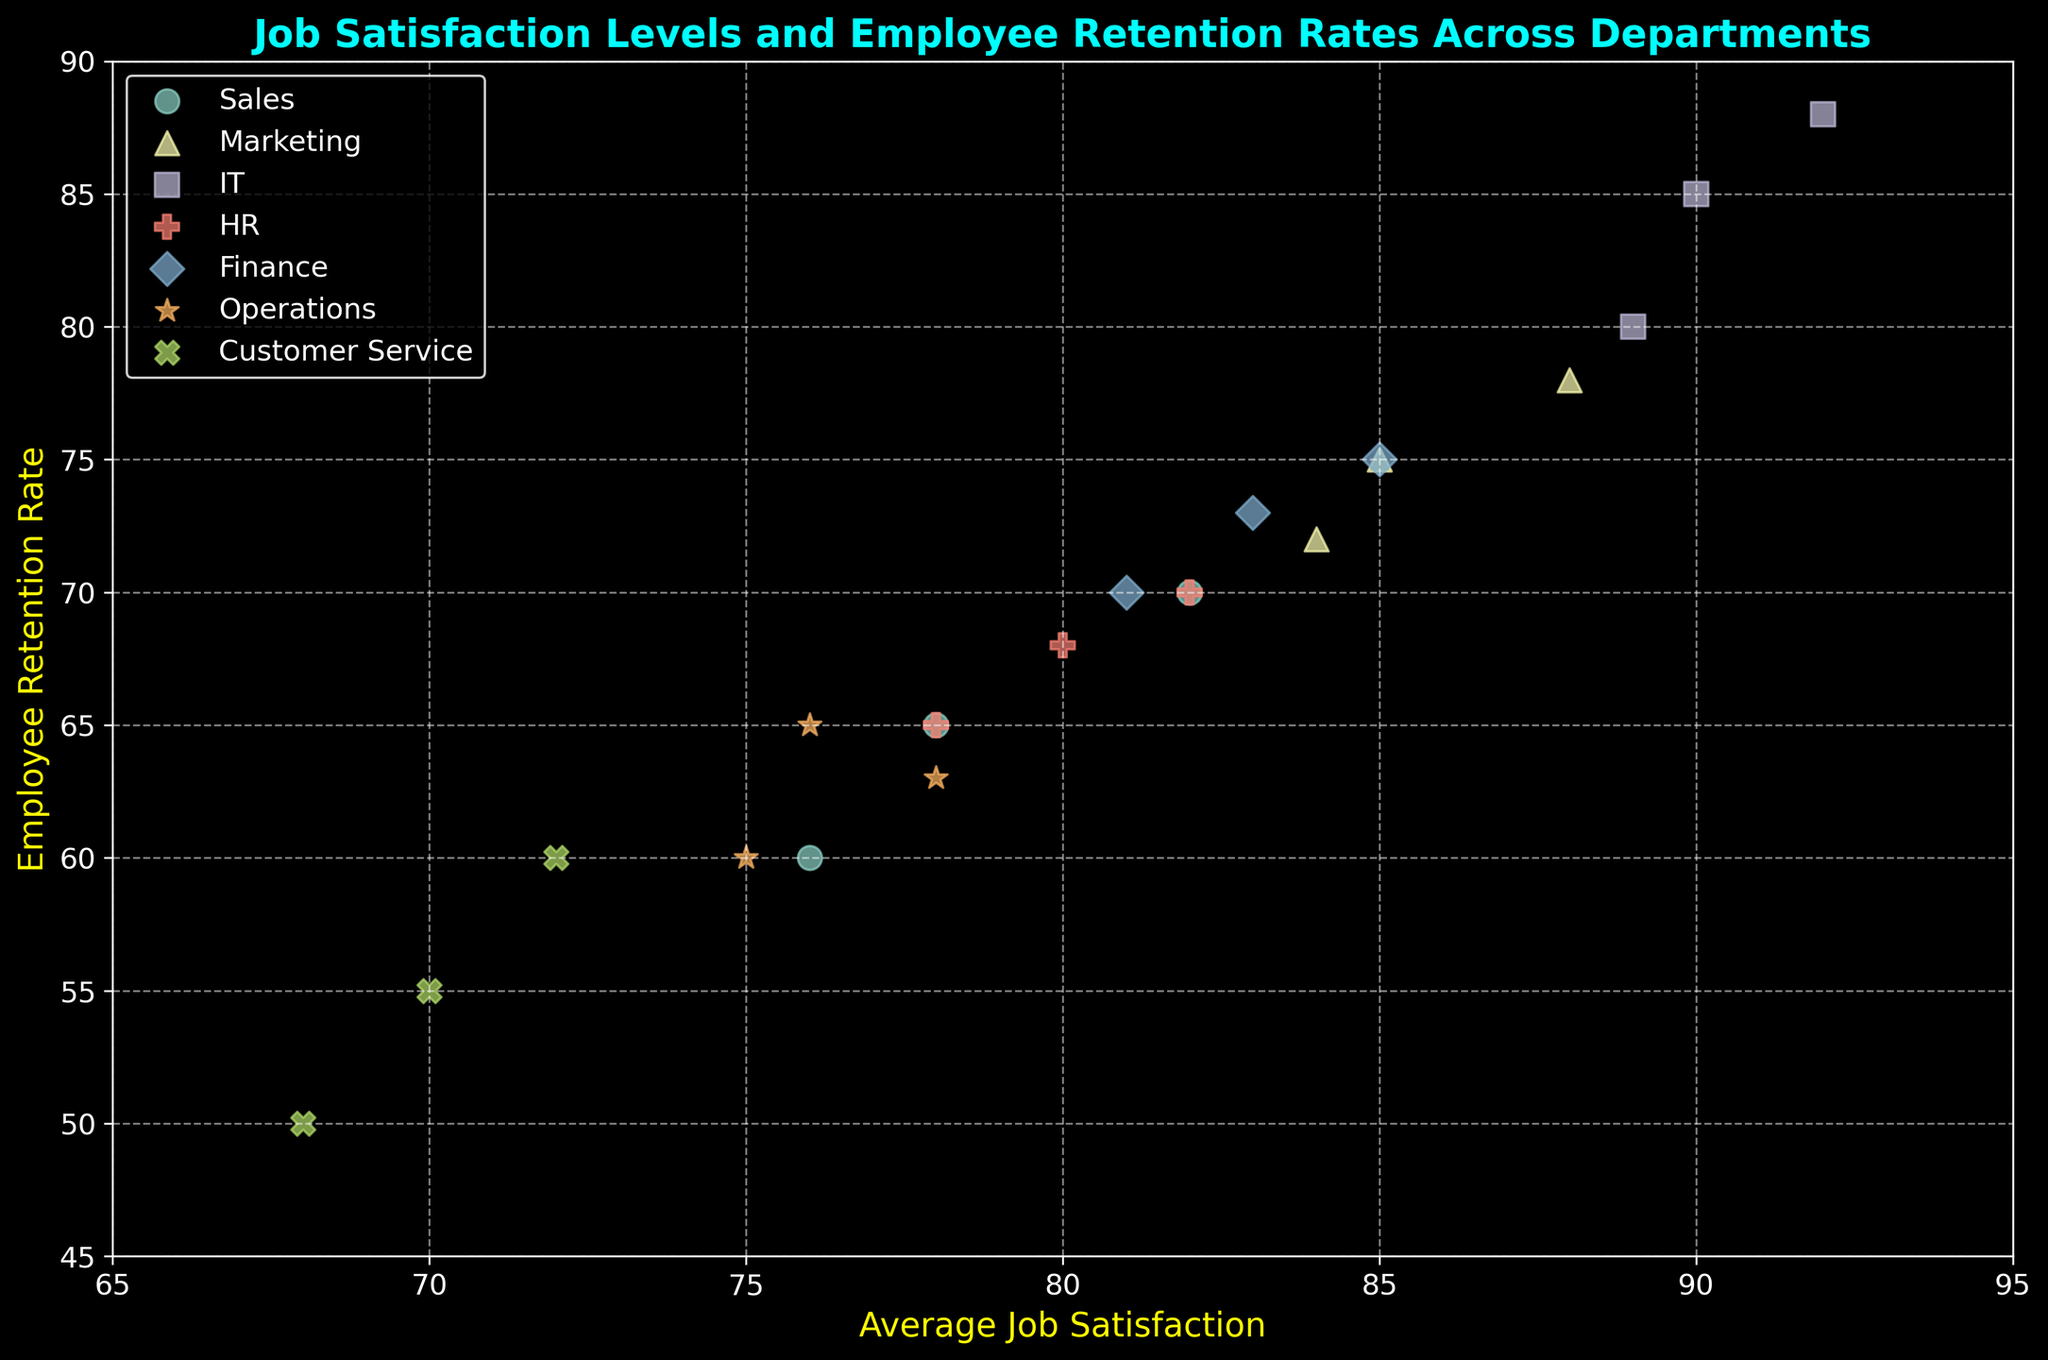What department has the highest average job satisfaction? Look at the x-axis values for all points and identify the department with the highest x-axis value. The IT department shows the highest average job satisfaction of 92.
Answer: IT What is the difference between the highest and lowest employee retention rates across all departments? Identify the highest and lowest y-axis values from the plot. The highest retention rate is 88 (IT) and the lowest is 50 (Customer Service). Calculate the difference: 88 - 50 = 38.
Answer: 38 Which department has the lowest average job satisfaction? Look at the x-axis values for all points and identify the department with the lowest x-axis value. Customer Service shows the lowest average job satisfaction of 68.
Answer: Customer Service Which department has a higher job satisfaction: Sales or Marketing? Compare the x-axis values for all points within Sales and Marketing. Marketing's values (85, 88, 84) are higher compared to Sales' values (78, 82, 76).
Answer: Marketing Which department's data points show the most significant variation in retention rates? Look at the spread of y-axis values for each department's points. Customer Service varies from 50 to 60, a range of 10, while other departments have tighter ranges. Customer Service has the most significant spread in retention rates.
Answer: Customer Service What is the average employee retention rate for the HR department? Identify the y-axis values for HR (68, 70, 65) and calculate the average: (68 + 70 + 65)/3 = 67.67.
Answer: 67.67 How does the retention rate for Finance compare to Operations? Compare the y-axis values for Finance and Operations. Finance's values (73, 75, 70) are generally higher than Operations' values (60, 63, 65).
Answer: Finance is higher What is the range of job satisfaction scores within the Marketing department? Identify the x-axis values for Marketing (85, 88, 84) and calculate the range: 88 - 84 = 4.
Answer: 4 How do the retention rates for IT and HR compare? Compare the y-axis values for IT (85, 88, 80) and HR (68, 70, 65). IT generally has higher retention rates compared to HR.
Answer: IT is higher Is there a correlation between job satisfaction and retention rate in the figure? Observe the overall trend of the points. Higher job satisfaction on the x-axis corresponds to higher retention rates on the y-axis, indicating a positive correlation.
Answer: Yes 